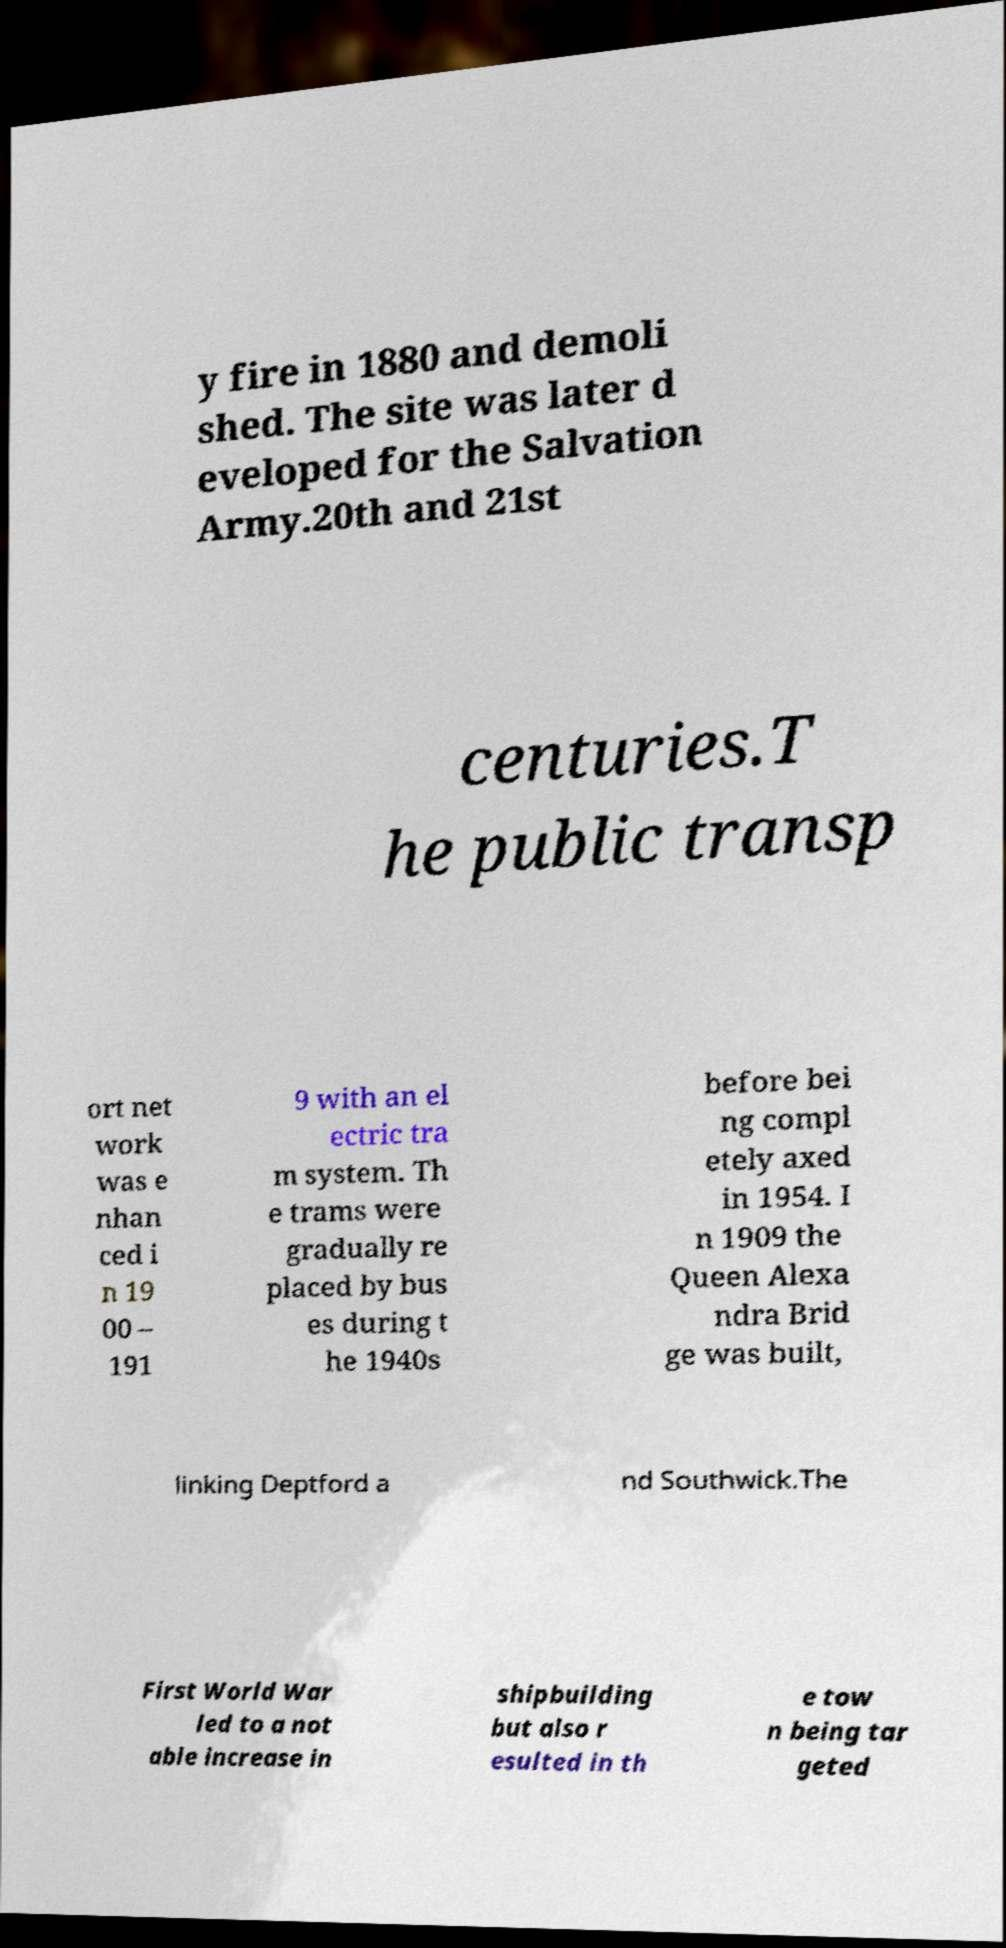Can you accurately transcribe the text from the provided image for me? y fire in 1880 and demoli shed. The site was later d eveloped for the Salvation Army.20th and 21st centuries.T he public transp ort net work was e nhan ced i n 19 00 – 191 9 with an el ectric tra m system. Th e trams were gradually re placed by bus es during t he 1940s before bei ng compl etely axed in 1954. I n 1909 the Queen Alexa ndra Brid ge was built, linking Deptford a nd Southwick.The First World War led to a not able increase in shipbuilding but also r esulted in th e tow n being tar geted 